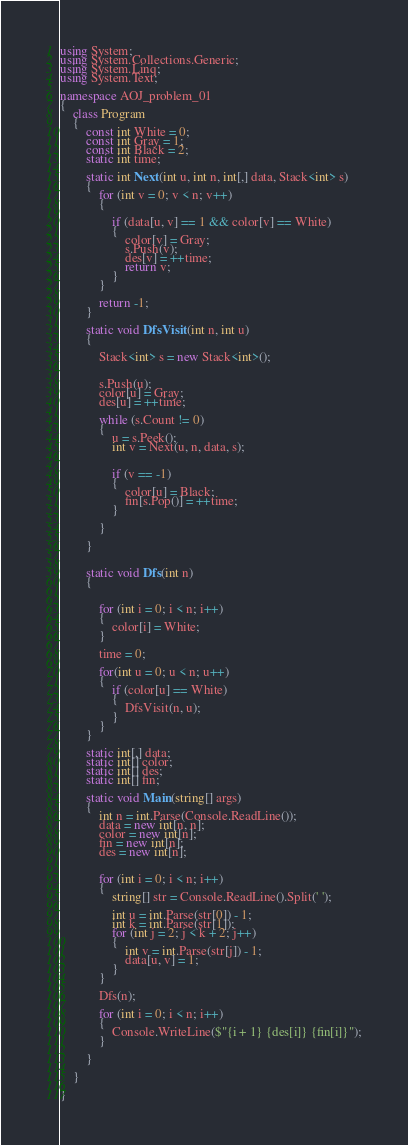<code> <loc_0><loc_0><loc_500><loc_500><_C#_>using System;
using System.Collections.Generic;
using System.Linq;
using System.Text;

namespace AOJ_problem_01
{
    class Program
    {
        const int White = 0;
        const int Gray = 1;
        const int Black = 2;
        static int time;

        static int Next(int u, int n, int[,] data, Stack<int> s)
        {
            for (int v = 0; v < n; v++)
            {
                
                if (data[u, v] == 1 && color[v] == White)
                {
                    color[v] = Gray;
                    s.Push(v);
                    des[v] = ++time;
                    return v;
                }
            }

            return -1; 
        }

        static void DfsVisit(int n, int u)
        {
              
            Stack<int> s = new Stack<int>();

           
            s.Push(u);
            color[u] = Gray;
            des[u] = ++time;

            while (s.Count != 0)
            {
                u = s.Peek();
                int v = Next(u, n, data, s);

                
                if (v == -1)
                {
                    color[u] = Black;
                    fin[s.Pop()] = ++time;
                }

            }

        }

       
        static void Dfs(int n)
        {

            
            for (int i = 0; i < n; i++)
            {
                color[i] = White;
            }

            time = 0;  

            for(int u = 0; u < n; u++)
            {
                if (color[u] == White)
                {
                    DfsVisit(n, u);
                }
            }
        }

        static int[,] data;
        static int[] color;
        static int[] des;
        static int[] fin;

        static void Main(string[] args)
        {
            int n = int.Parse(Console.ReadLine());
            data = new int[n, n];
            color = new int[n];
            fin = new int[n];
            des = new int[n];

           
            for (int i = 0; i < n; i++)
            {
                string[] str = Console.ReadLine().Split(' ');

                int u = int.Parse(str[0]) - 1;
                int k = int.Parse(str[1]);
                for (int j = 2; j < k + 2; j++)
                {
                    int v = int.Parse(str[j]) - 1;   
                    data[u, v] = 1;      
                }
            }

            Dfs(n);

            for (int i = 0; i < n; i++)
            {
                Console.WriteLine($"{i + 1} {des[i]} {fin[i]}");
            }

        }

    }

}


</code> 